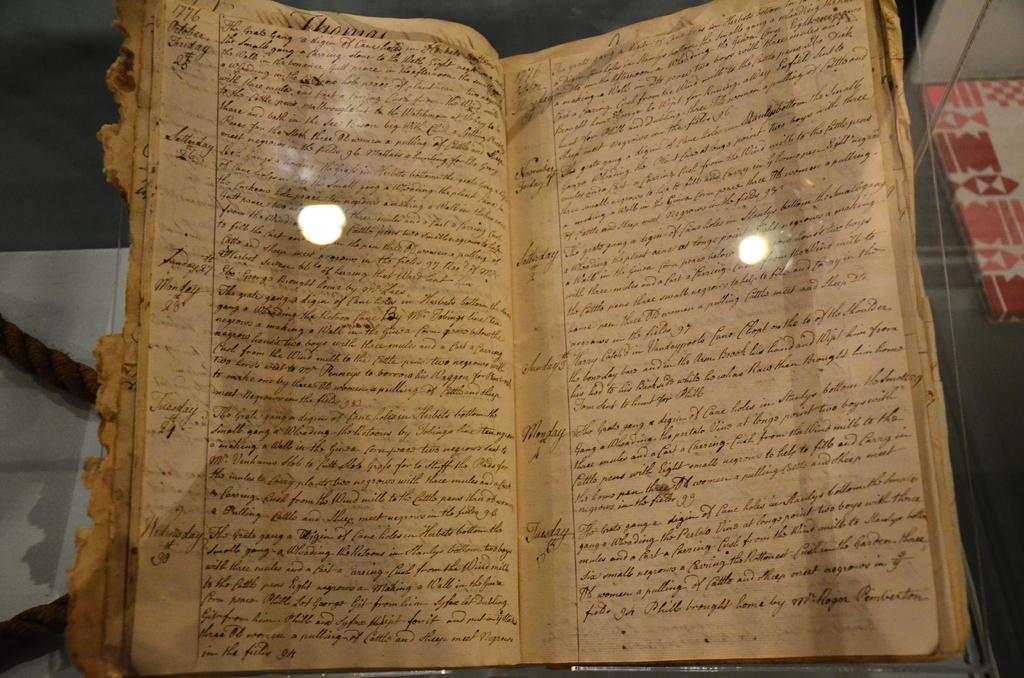<image>
Summarize the visual content of the image. A chewed up and worn out logbook with days like Monday and Tuesday written on the side. 